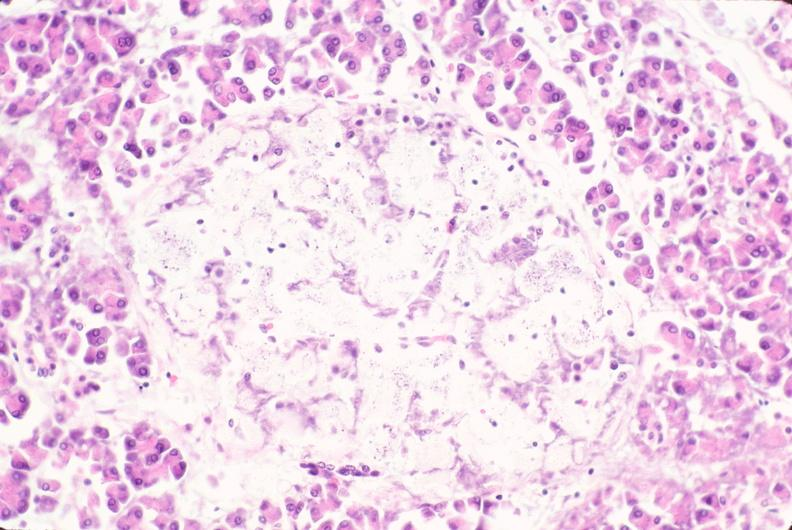what is present?
Answer the question using a single word or phrase. Endocrine 